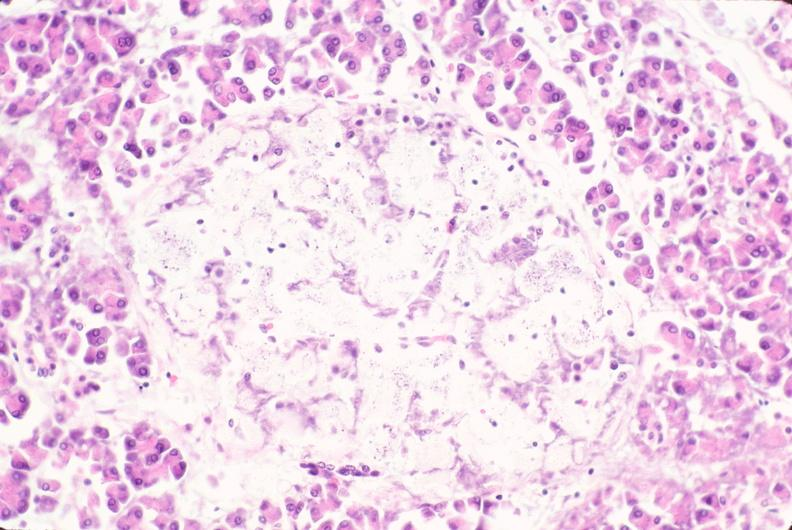what is present?
Answer the question using a single word or phrase. Endocrine 